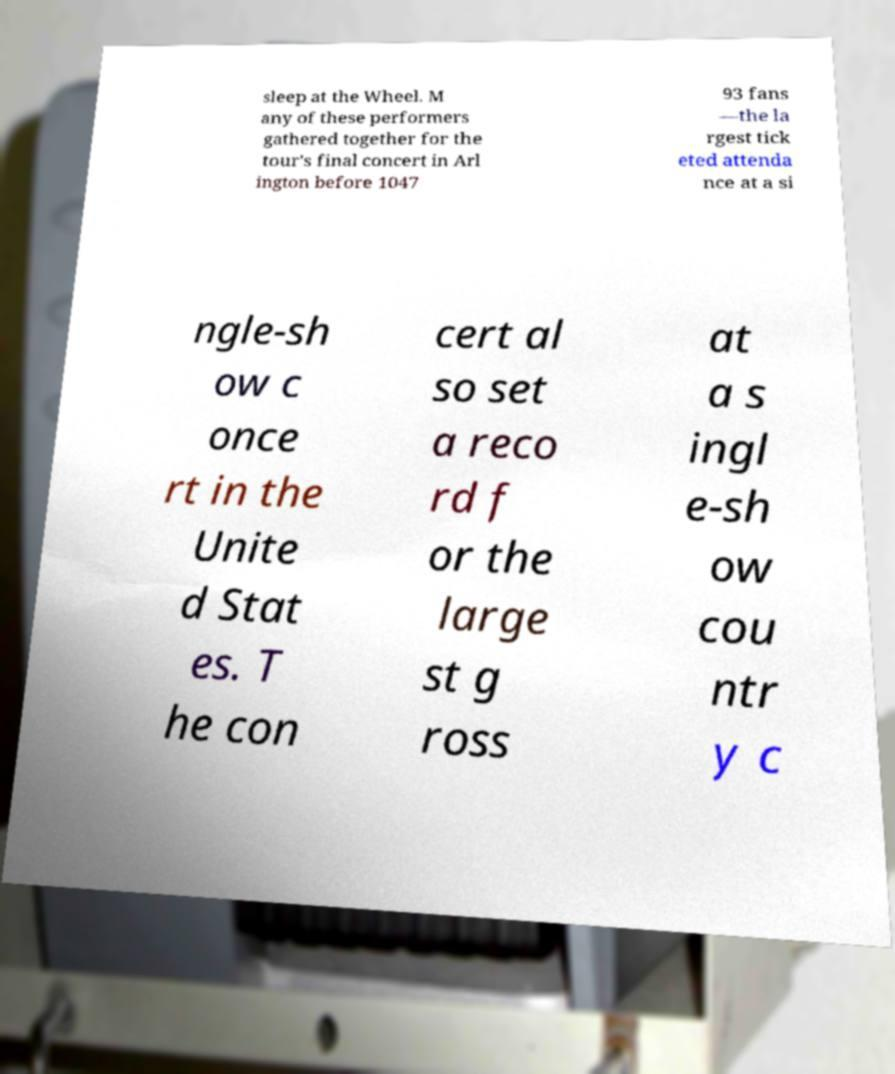Can you read and provide the text displayed in the image?This photo seems to have some interesting text. Can you extract and type it out for me? sleep at the Wheel. M any of these performers gathered together for the tour's final concert in Arl ington before 1047 93 fans —the la rgest tick eted attenda nce at a si ngle-sh ow c once rt in the Unite d Stat es. T he con cert al so set a reco rd f or the large st g ross at a s ingl e-sh ow cou ntr y c 